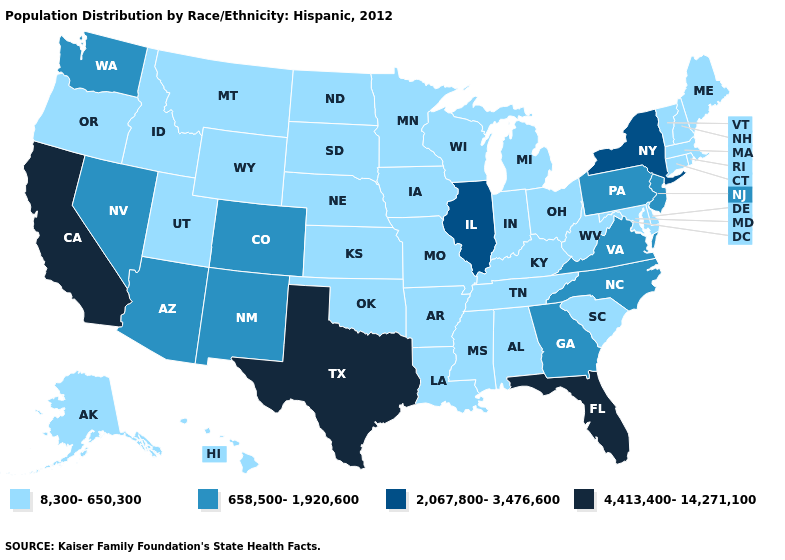Which states have the lowest value in the USA?
Short answer required. Alabama, Alaska, Arkansas, Connecticut, Delaware, Hawaii, Idaho, Indiana, Iowa, Kansas, Kentucky, Louisiana, Maine, Maryland, Massachusetts, Michigan, Minnesota, Mississippi, Missouri, Montana, Nebraska, New Hampshire, North Dakota, Ohio, Oklahoma, Oregon, Rhode Island, South Carolina, South Dakota, Tennessee, Utah, Vermont, West Virginia, Wisconsin, Wyoming. Name the states that have a value in the range 658,500-1,920,600?
Short answer required. Arizona, Colorado, Georgia, Nevada, New Jersey, New Mexico, North Carolina, Pennsylvania, Virginia, Washington. Which states hav the highest value in the West?
Quick response, please. California. What is the lowest value in the USA?
Short answer required. 8,300-650,300. What is the value of New Hampshire?
Concise answer only. 8,300-650,300. Name the states that have a value in the range 8,300-650,300?
Keep it brief. Alabama, Alaska, Arkansas, Connecticut, Delaware, Hawaii, Idaho, Indiana, Iowa, Kansas, Kentucky, Louisiana, Maine, Maryland, Massachusetts, Michigan, Minnesota, Mississippi, Missouri, Montana, Nebraska, New Hampshire, North Dakota, Ohio, Oklahoma, Oregon, Rhode Island, South Carolina, South Dakota, Tennessee, Utah, Vermont, West Virginia, Wisconsin, Wyoming. Does the map have missing data?
Write a very short answer. No. Name the states that have a value in the range 658,500-1,920,600?
Give a very brief answer. Arizona, Colorado, Georgia, Nevada, New Jersey, New Mexico, North Carolina, Pennsylvania, Virginia, Washington. What is the highest value in states that border Alabama?
Give a very brief answer. 4,413,400-14,271,100. Does Maine have the lowest value in the Northeast?
Quick response, please. Yes. Does Oklahoma have the lowest value in the USA?
Answer briefly. Yes. Among the states that border Wisconsin , does Minnesota have the lowest value?
Quick response, please. Yes. What is the highest value in states that border West Virginia?
Quick response, please. 658,500-1,920,600. What is the value of Oklahoma?
Quick response, please. 8,300-650,300. Name the states that have a value in the range 8,300-650,300?
Keep it brief. Alabama, Alaska, Arkansas, Connecticut, Delaware, Hawaii, Idaho, Indiana, Iowa, Kansas, Kentucky, Louisiana, Maine, Maryland, Massachusetts, Michigan, Minnesota, Mississippi, Missouri, Montana, Nebraska, New Hampshire, North Dakota, Ohio, Oklahoma, Oregon, Rhode Island, South Carolina, South Dakota, Tennessee, Utah, Vermont, West Virginia, Wisconsin, Wyoming. 